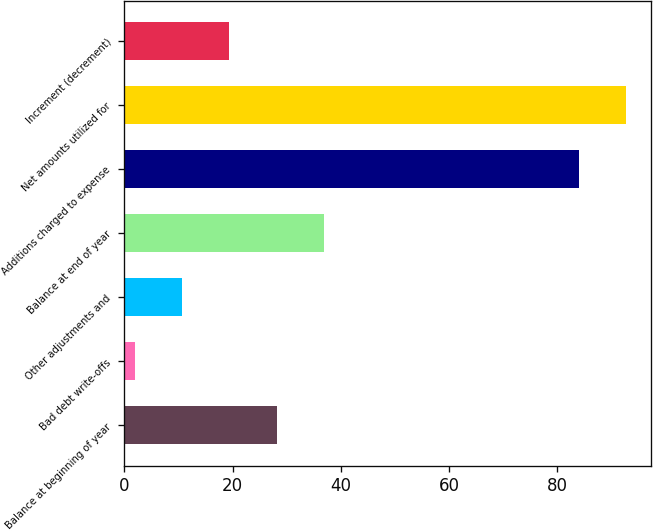Convert chart to OTSL. <chart><loc_0><loc_0><loc_500><loc_500><bar_chart><fcel>Balance at beginning of year<fcel>Bad debt write-offs<fcel>Other adjustments and<fcel>Balance at end of year<fcel>Additions charged to expense<fcel>Net amounts utilized for<fcel>Increment (decrement)<nl><fcel>28.1<fcel>2<fcel>10.7<fcel>36.8<fcel>84<fcel>92.7<fcel>19.4<nl></chart> 